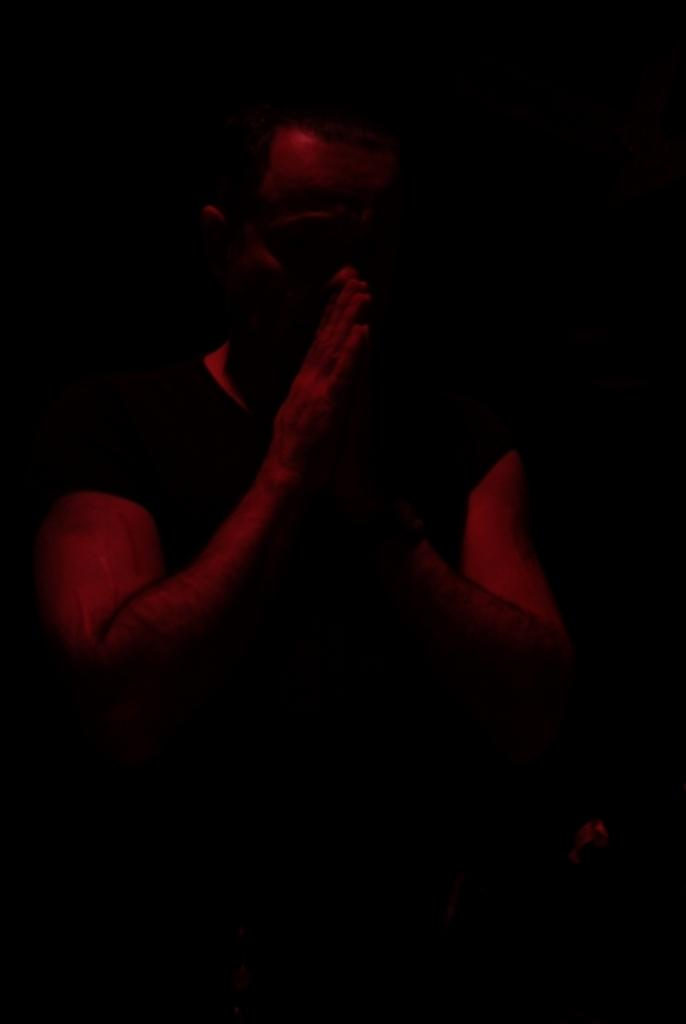Who or what is the main subject in the image? There is a person in the image. What is the person doing in the image? The person is folding their hands. Can you describe the background of the image? The background of the image is dark. What type of donkey can be seen in the image? There is no donkey present in the image. What does the person wish for in the image? There is no indication of a wish in the image. 